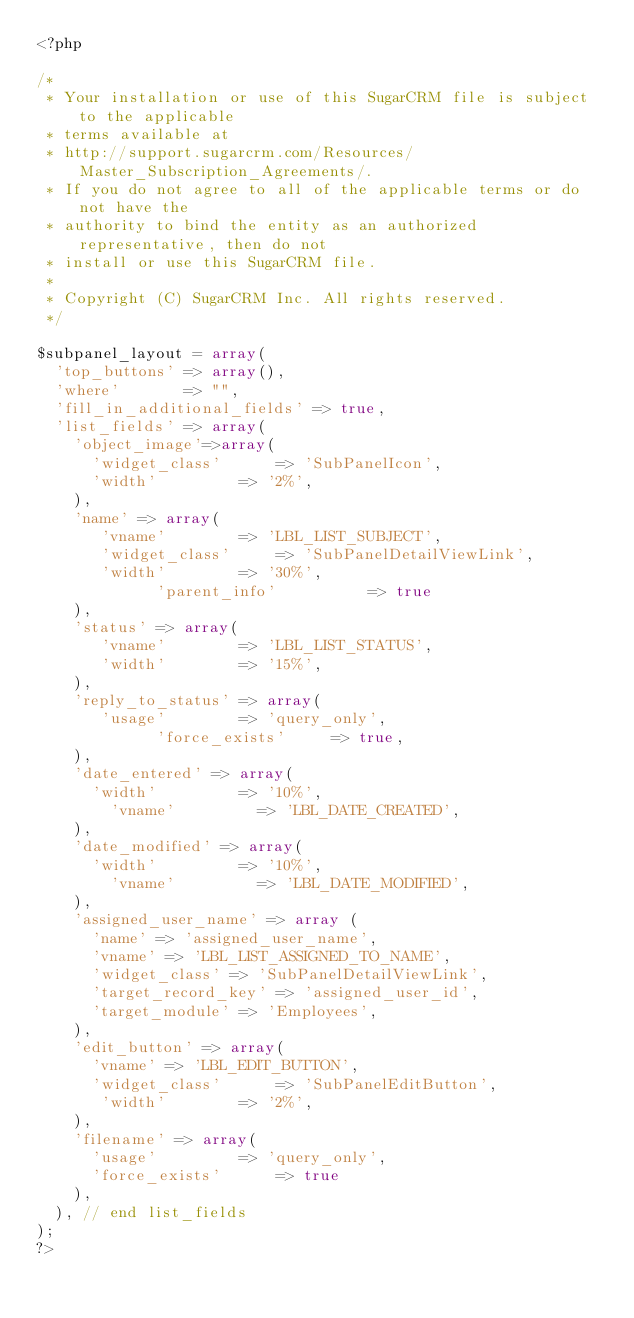<code> <loc_0><loc_0><loc_500><loc_500><_PHP_><?php

/*
 * Your installation or use of this SugarCRM file is subject to the applicable
 * terms available at
 * http://support.sugarcrm.com/Resources/Master_Subscription_Agreements/.
 * If you do not agree to all of the applicable terms or do not have the
 * authority to bind the entity as an authorized representative, then do not
 * install or use this SugarCRM file.
 *
 * Copyright (C) SugarCRM Inc. All rights reserved.
 */

$subpanel_layout = array(
	'top_buttons' => array(),
	'where'				=> "",
	'fill_in_additional_fields'	=> true,
	'list_fields' => array(
		'object_image'=>array(
			'widget_class'			=> 'SubPanelIcon',
 		 	'width'					=> '2%',
		),
		'name' => array(
			 'vname'				=> 'LBL_LIST_SUBJECT',
			 'widget_class'			=> 'SubPanelDetailViewLink',
			 'width'				=> '30%',
             'parent_info'          => true
		),
		'status' => array(
			 'vname'				=> 'LBL_LIST_STATUS',
			 'width'				=> '15%',
		),
		'reply_to_status' => array(
			 'usage'				=> 'query_only',
             'force_exists'			=> true,
		),
		'date_entered' => array(
			'width'					=> '10%',
		    'vname'					=> 'LBL_DATE_CREATED',
		),
		'date_modified' => array(
			'width'					=> '10%',
		    'vname'					=> 'LBL_DATE_MODIFIED',
		),
		'assigned_user_name' => array (
			'name' => 'assigned_user_name',
			'vname' => 'LBL_LIST_ASSIGNED_TO_NAME',
			'widget_class' => 'SubPanelDetailViewLink',
		 	'target_record_key' => 'assigned_user_id',
			'target_module' => 'Employees',
		),
		'edit_button' => array(
			'vname' => 'LBL_EDIT_BUTTON',
			'widget_class'			=> 'SubPanelEditButton',
			 'width'				=> '2%',
		),
		'filename' => array(
			'usage'					=> 'query_only',
			'force_exists'			=> true
		),
	), // end list_fields
);
?>
</code> 